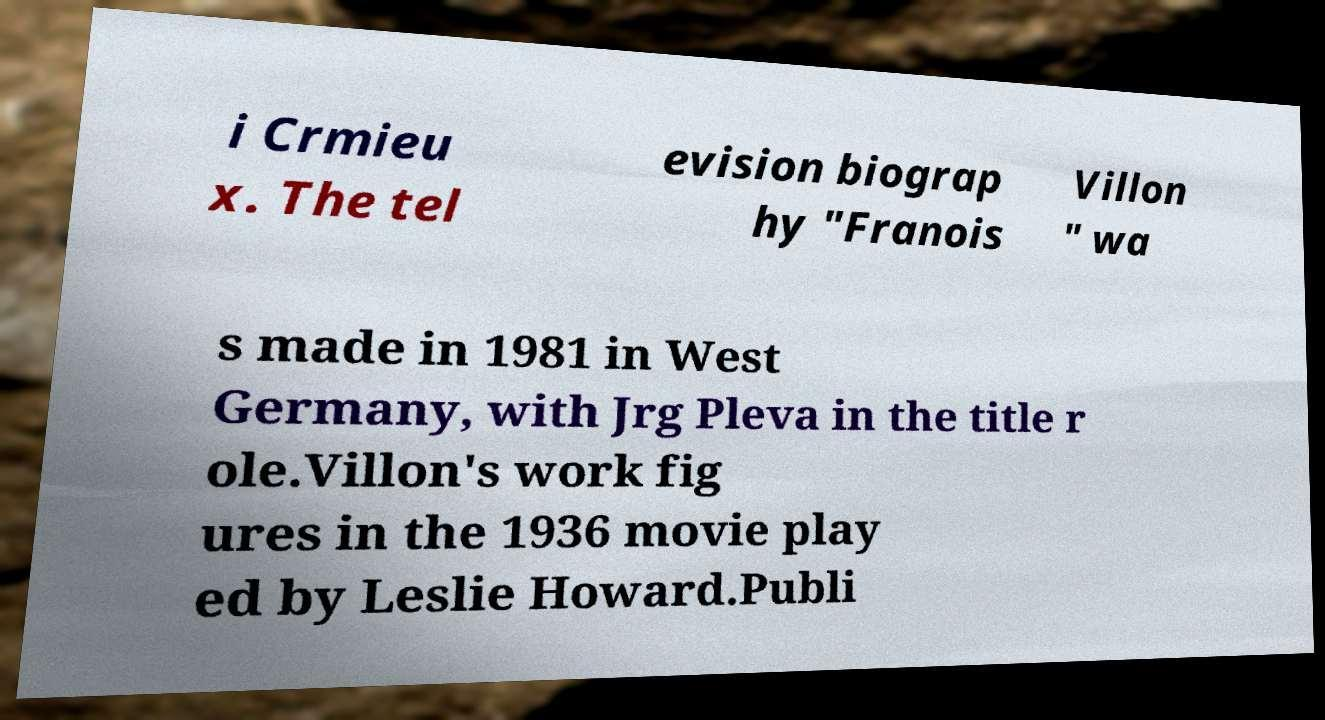Please identify and transcribe the text found in this image. i Crmieu x. The tel evision biograp hy "Franois Villon " wa s made in 1981 in West Germany, with Jrg Pleva in the title r ole.Villon's work fig ures in the 1936 movie play ed by Leslie Howard.Publi 